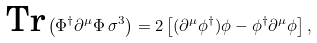Convert formula to latex. <formula><loc_0><loc_0><loc_500><loc_500>\text {Tr} \left ( \Phi ^ { \dagger } \partial ^ { \mu } \Phi \, \sigma ^ { 3 } \right ) = 2 \left [ ( \partial ^ { \mu } \phi ^ { \dagger } ) \phi - \phi ^ { \dagger } \partial ^ { \mu } \phi \right ] ,</formula> 